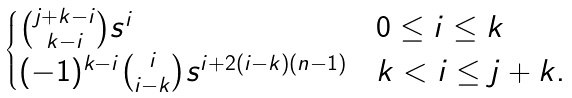<formula> <loc_0><loc_0><loc_500><loc_500>\begin{cases} \binom { j + k - i } { k - i } s ^ { i } & 0 \leq i \leq k \\ ( - 1 ) ^ { k - i } \binom { i } { i - k } s ^ { i + 2 ( i - k ) ( n - 1 ) } & k < i \leq j + k . \end{cases}</formula> 